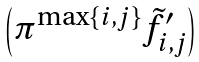Convert formula to latex. <formula><loc_0><loc_0><loc_500><loc_500>\begin{pmatrix} \pi ^ { \max \{ i , j \} } \tilde { f } _ { i , j } ^ { \prime } \end{pmatrix}</formula> 